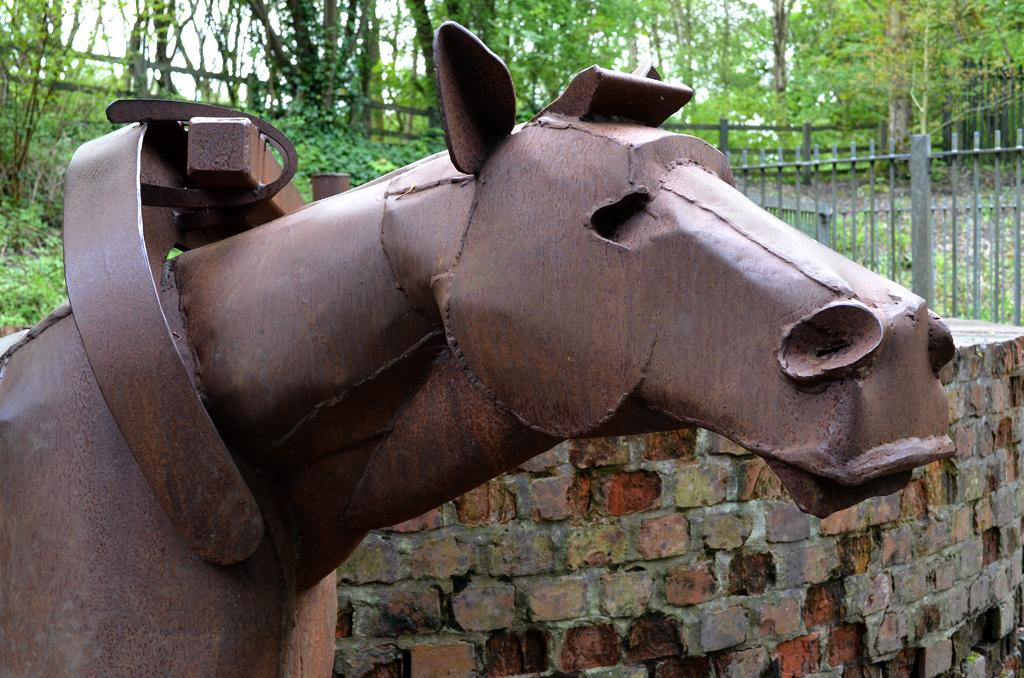What is the main subject in the foreground of the image? There is a metal horse in the foreground of the image. What other object is present in the foreground of the image? There is a brick wall in the foreground of the image. What can be seen in the background of the image? There is a fence, plants, trees, and the sky visible in the background of the image. Can you describe the setting where the image might have been taken? The image may have been taken near a park, given the presence of plants, trees, and the fence. What type of tin can be seen in the image? There is no tin present in the image. Is there a bear visible in the image? No, there is no bear present in the image. 